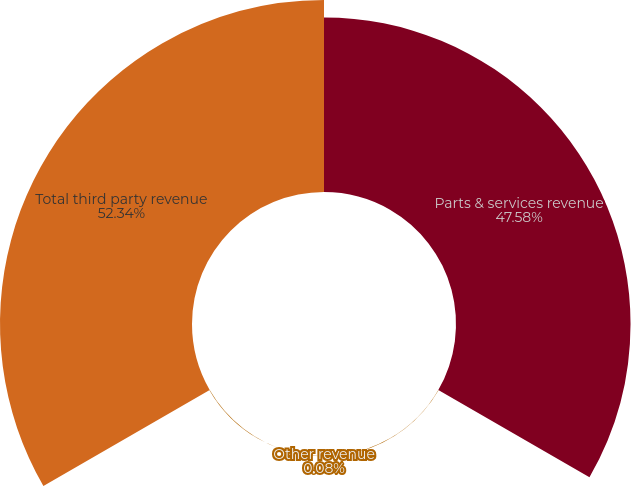Convert chart. <chart><loc_0><loc_0><loc_500><loc_500><pie_chart><fcel>Parts & services revenue<fcel>Other revenue<fcel>Total third party revenue<nl><fcel>47.58%<fcel>0.08%<fcel>52.34%<nl></chart> 